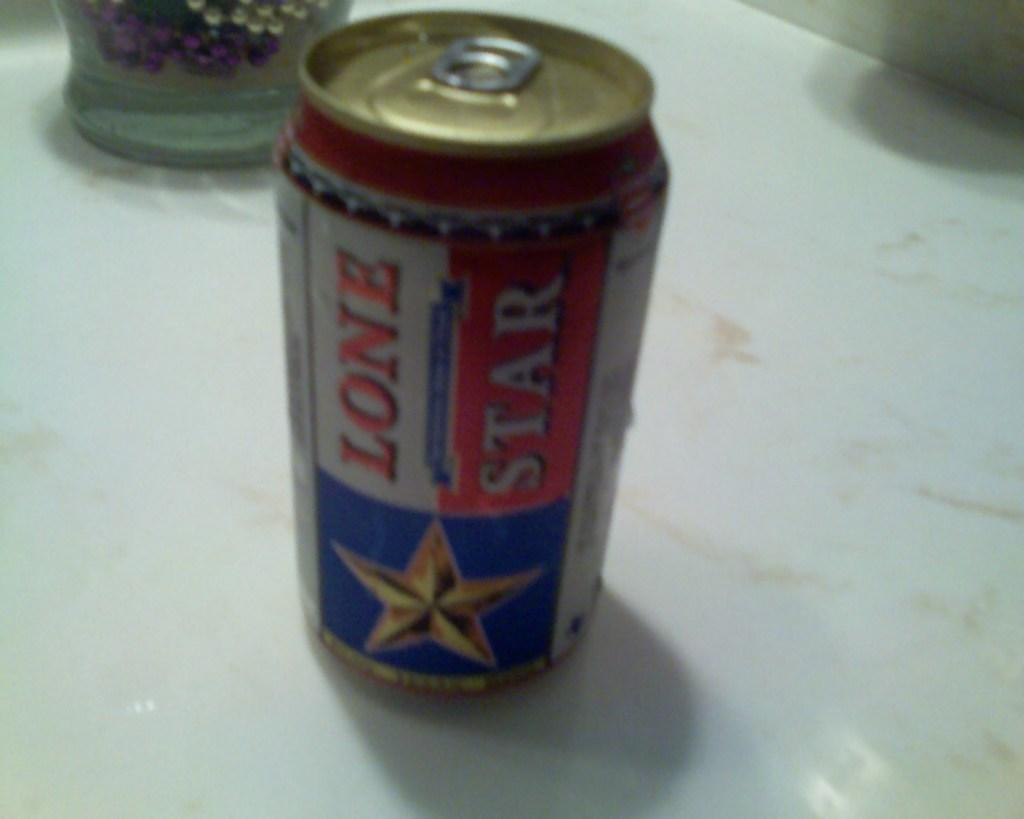<image>
Render a clear and concise summary of the photo. Can of beer that says Lone Star in red and white. 